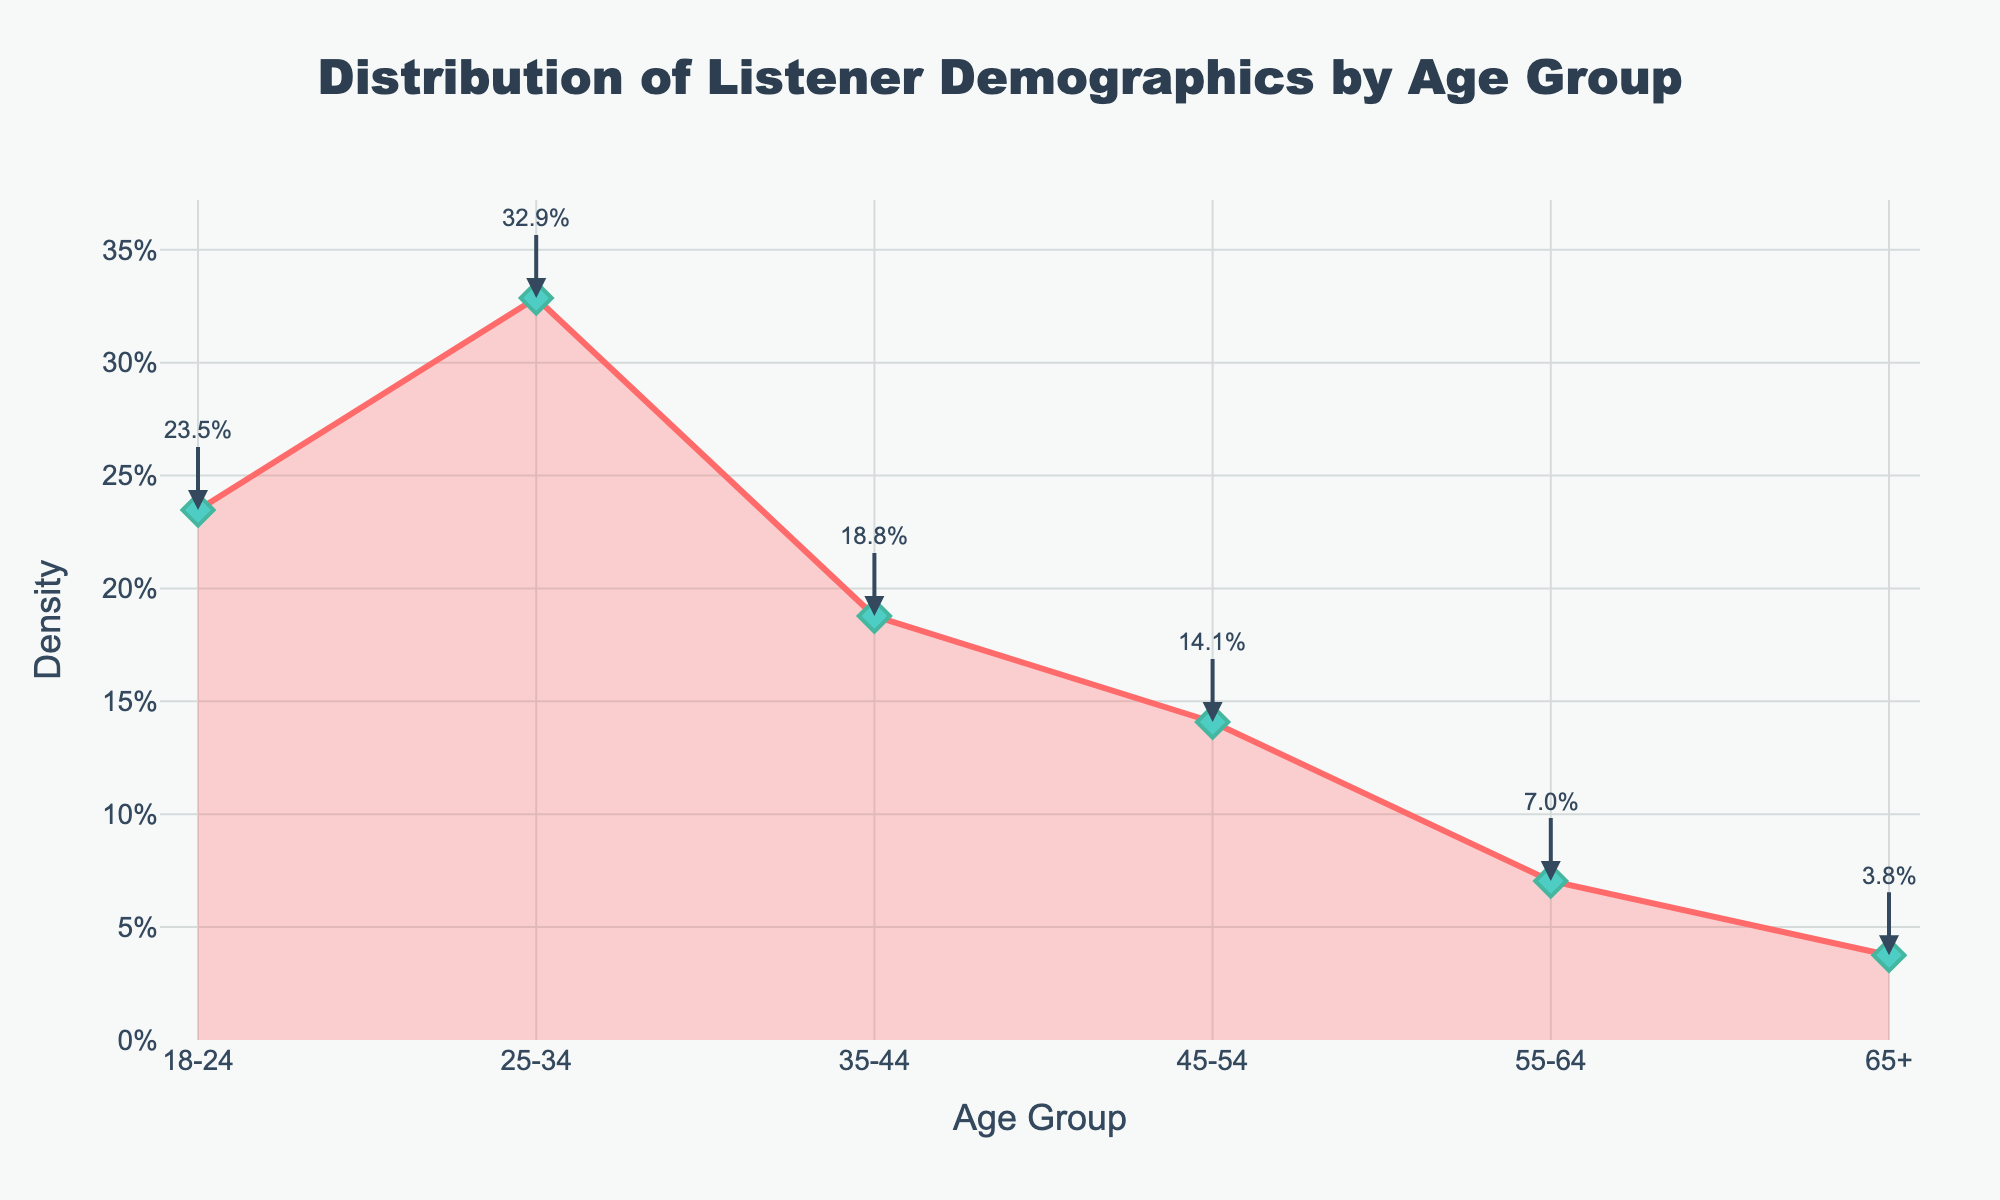What is the title of the plot? The title of the plot is written at the top and center and reads "Distribution of Listener Demographics by Age Group".
Answer: Distribution of Listener Demographics by Age Group What are the age groups shown on the x-axis? The x-axis represents the age groups with labels: 18-24, 25-34, 35-44, 45-54, 55-64, and 65+.
Answer: 18-24, 25-34, 35-44, 45-54, 55-64, 65+ What is the density value for the age group 25-34? The density value for the age group 25-34 can be found marked on the plot with an annotation near the corresponding age group. It reads 23.3%.
Answer: 23.3% Which age group has the highest density of listeners? The age group with the highest density is the one with the highest data point on the y-axis graph and is annotated. The annotation shows 32.2% for 18-24.
Answer: 18-24 What is the sum of densities for age groups 18-24 and 25-34? The density for 18-24 is 32.2% and for 25-34 is 23.3%. Adding them gives 32.2% + 23.3% = 55.5%.
Answer: 55.5% How does the density for age group 35-44 compare to age group 45-54? Age group 35-44 has a density of 16.7%, and age group 45-54 has a density of 12.5%. The density of 35-44 is higher than 45-54.
Answer: 35-44 > 45-54 What percentage of listeners are aged 65+? The percentage of listeners aged 65+ is annotated on the plot next to the corresponding age group. It reads 5.2%.
Answer: 5.2% Which age group has the smallest density of listeners? The smallest density value is annotated on the plot, and the lowest value is 5.2% corresponding to the age group 65+.
Answer: 65+ What is the difference in density between the age groups 25-34 and 55-64? The density for age group 25-34 is 23.3% and for 55-64 is 5%. The difference is 23.3% - 5% = 18.3%.
Answer: 18.3% What trend do you observe in the densities as the age groups increase? Generally, the density starts high within younger age groups (18-24), decreases gradually, and reaches the lowest point at the 65+ age group. This shows a declining trend in density as age increases.
Answer: Decreasing trend 